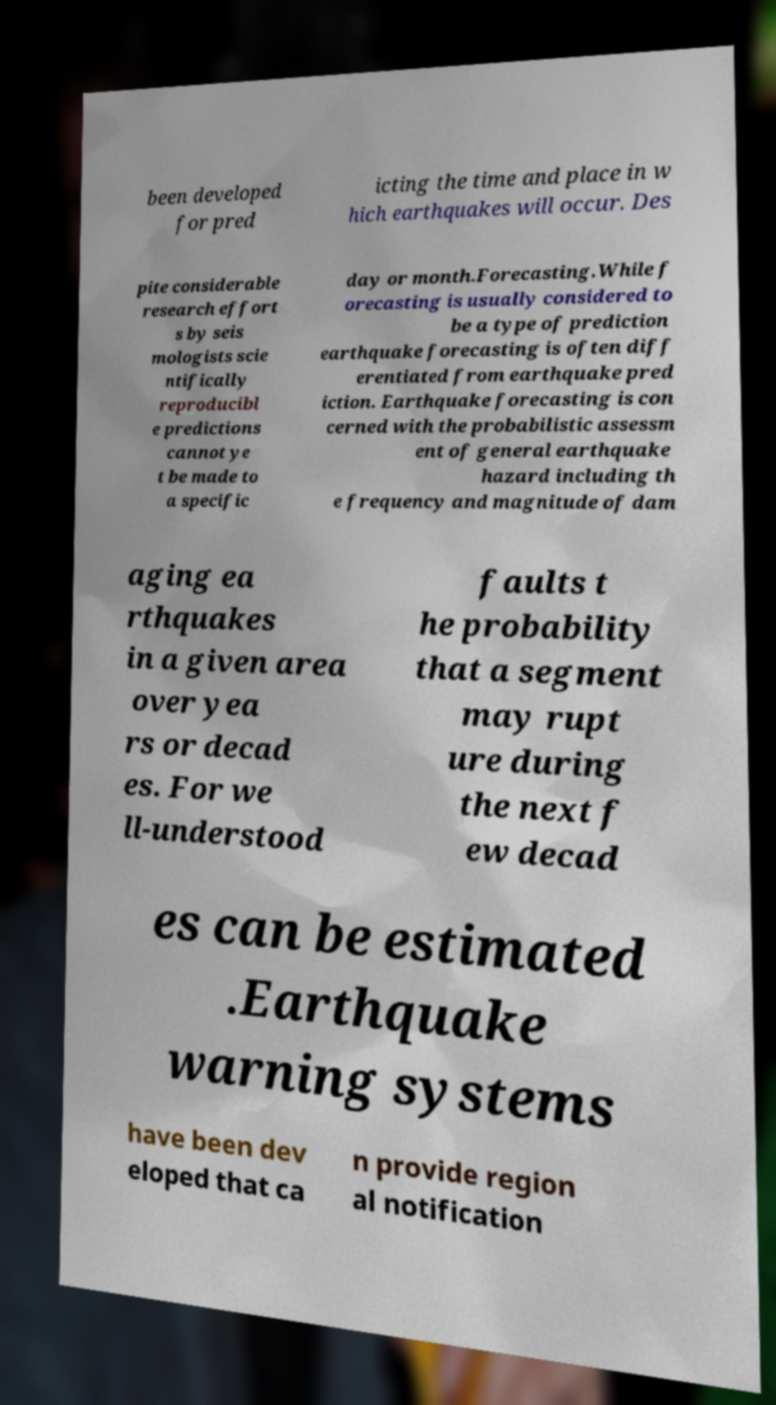I need the written content from this picture converted into text. Can you do that? been developed for pred icting the time and place in w hich earthquakes will occur. Des pite considerable research effort s by seis mologists scie ntifically reproducibl e predictions cannot ye t be made to a specific day or month.Forecasting.While f orecasting is usually considered to be a type of prediction earthquake forecasting is often diff erentiated from earthquake pred iction. Earthquake forecasting is con cerned with the probabilistic assessm ent of general earthquake hazard including th e frequency and magnitude of dam aging ea rthquakes in a given area over yea rs or decad es. For we ll-understood faults t he probability that a segment may rupt ure during the next f ew decad es can be estimated .Earthquake warning systems have been dev eloped that ca n provide region al notification 